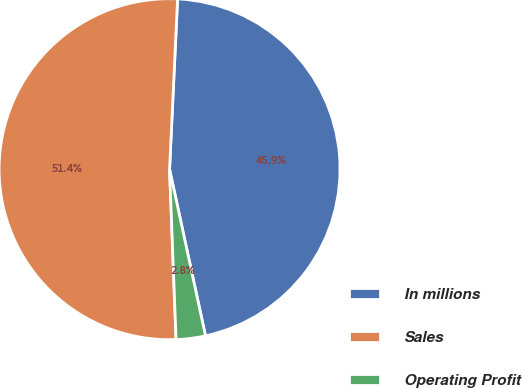Convert chart. <chart><loc_0><loc_0><loc_500><loc_500><pie_chart><fcel>In millions<fcel>Sales<fcel>Operating Profit<nl><fcel>45.87%<fcel>51.36%<fcel>2.77%<nl></chart> 